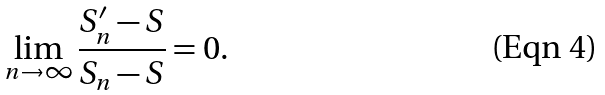<formula> <loc_0><loc_0><loc_500><loc_500>\lim _ { n \to \infty } \frac { S _ { n } ^ { \prime } - S } { S _ { n } - S } = 0 .</formula> 